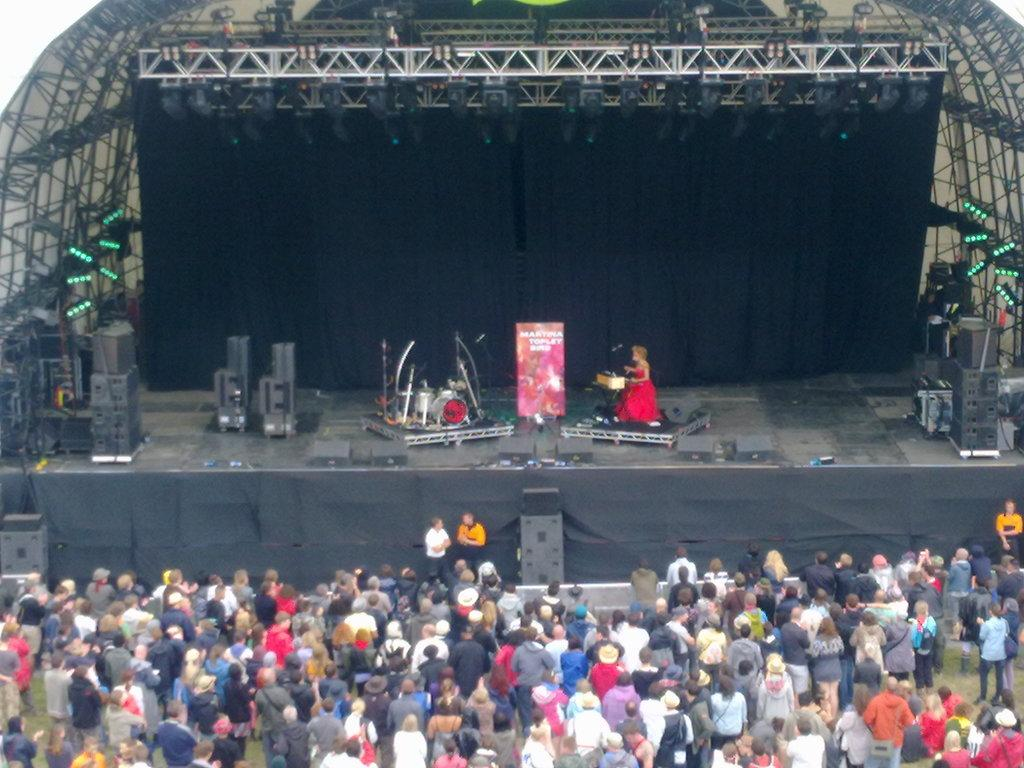What are the persons in the image wearing? The persons in the image are wearing clothes. What is the main feature in the middle of the image? There is a stage in the middle of the image. What can be found on the stage? The stage contains musical equipment. Can you see any farmers working near the river in the image? There is no farmer or river present in the image. What type of paint is being used on the musical equipment on the stage? There is no paint visible on the musical equipment in the image. 